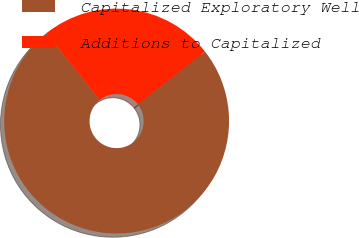Convert chart to OTSL. <chart><loc_0><loc_0><loc_500><loc_500><pie_chart><fcel>Capitalized Exploratory Well<fcel>Additions to Capitalized<nl><fcel>74.87%<fcel>25.13%<nl></chart> 